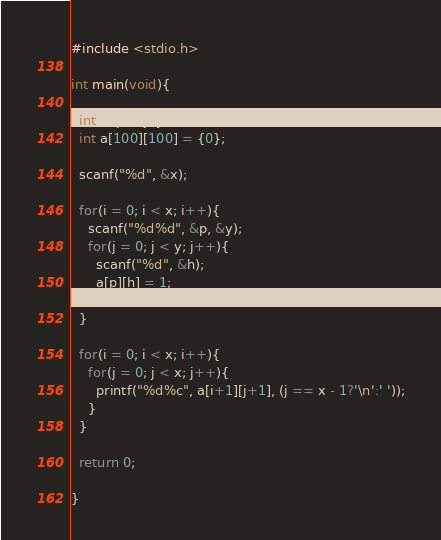<code> <loc_0><loc_0><loc_500><loc_500><_C_>#include <stdio.h>
 
int main(void){
 
  int x, p, i, j, y, h;
  int a[100][100] = {0};
     
  scanf("%d", &x);
   
  for(i = 0; i < x; i++){
    scanf("%d%d", &p, &y);
    for(j = 0; j < y; j++){
      scanf("%d", &h);
      a[p][h] = 1;
    }
  } 

  for(i = 0; i < x; i++){
    for(j = 0; j < x; j++){
      printf("%d%c", a[i+1][j+1], (j == x - 1?'\n':' '));
    }
  }

  return 0;

}</code> 